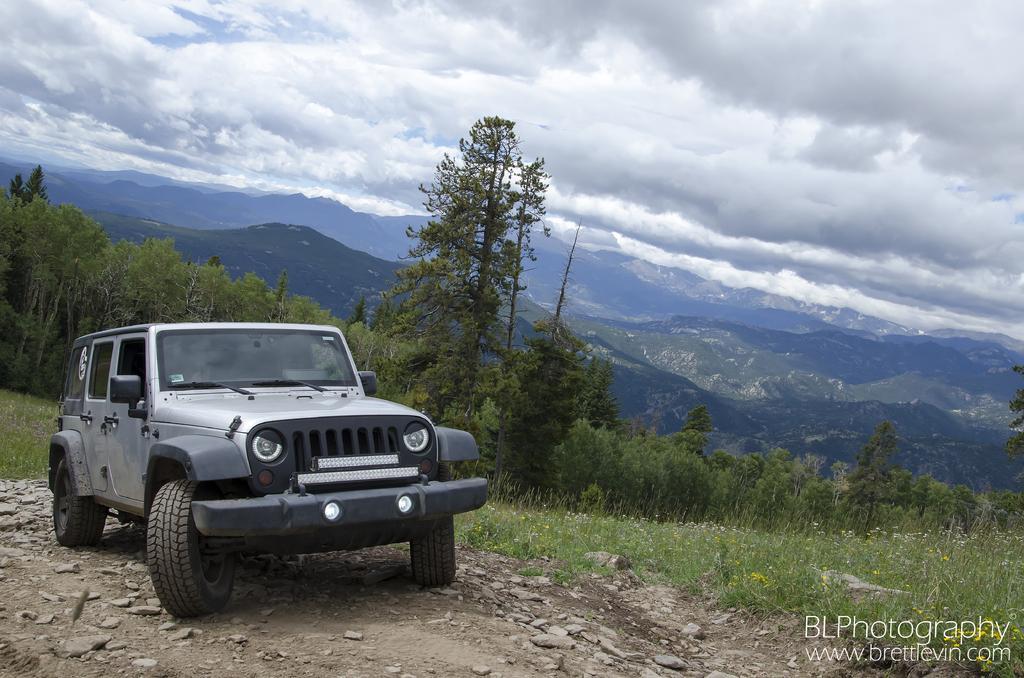Please provide a concise description of this image. This is an outside view. On the left side there is a vehicle on the ground. On the right side, I can see the plants along with the flowers. In the background there are many trees and mountains. At the top of the image I can see the sky and clouds. In the bottom right there is some edited text. 